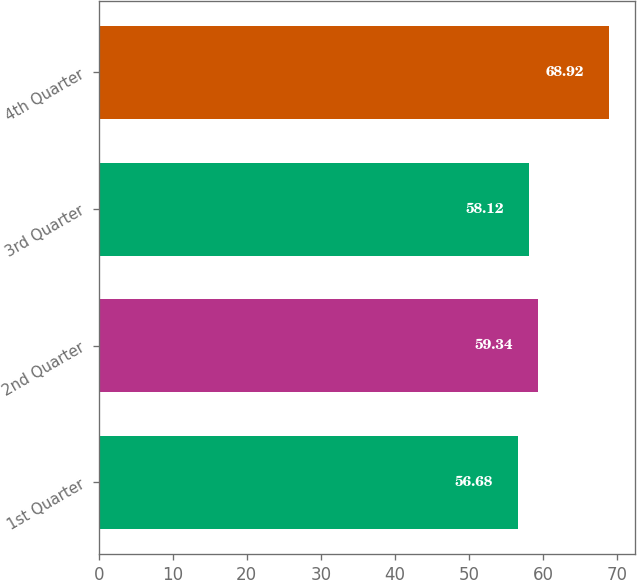Convert chart to OTSL. <chart><loc_0><loc_0><loc_500><loc_500><bar_chart><fcel>1st Quarter<fcel>2nd Quarter<fcel>3rd Quarter<fcel>4th Quarter<nl><fcel>56.68<fcel>59.34<fcel>58.12<fcel>68.92<nl></chart> 